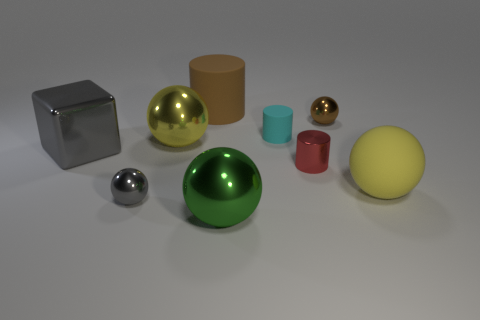Do the cyan thing and the gray metal cube have the same size?
Offer a terse response. No. What material is the large cylinder?
Your answer should be compact. Rubber. What material is the gray cube that is the same size as the yellow rubber thing?
Your answer should be compact. Metal. Is there another rubber thing of the same size as the red thing?
Provide a succinct answer. Yes. Are there the same number of tiny brown objects to the right of the tiny brown metal thing and tiny brown balls behind the cyan rubber object?
Your answer should be very brief. No. Is the number of shiny spheres greater than the number of large red spheres?
Give a very brief answer. Yes. What number of matte things are cylinders or small spheres?
Provide a short and direct response. 2. How many small things are the same color as the cube?
Offer a terse response. 1. What is the material of the tiny ball that is on the right side of the tiny shiny ball to the left of the small ball on the right side of the red metal cylinder?
Your answer should be very brief. Metal. What color is the big metal object that is in front of the small ball that is left of the cyan matte thing?
Your answer should be compact. Green. 